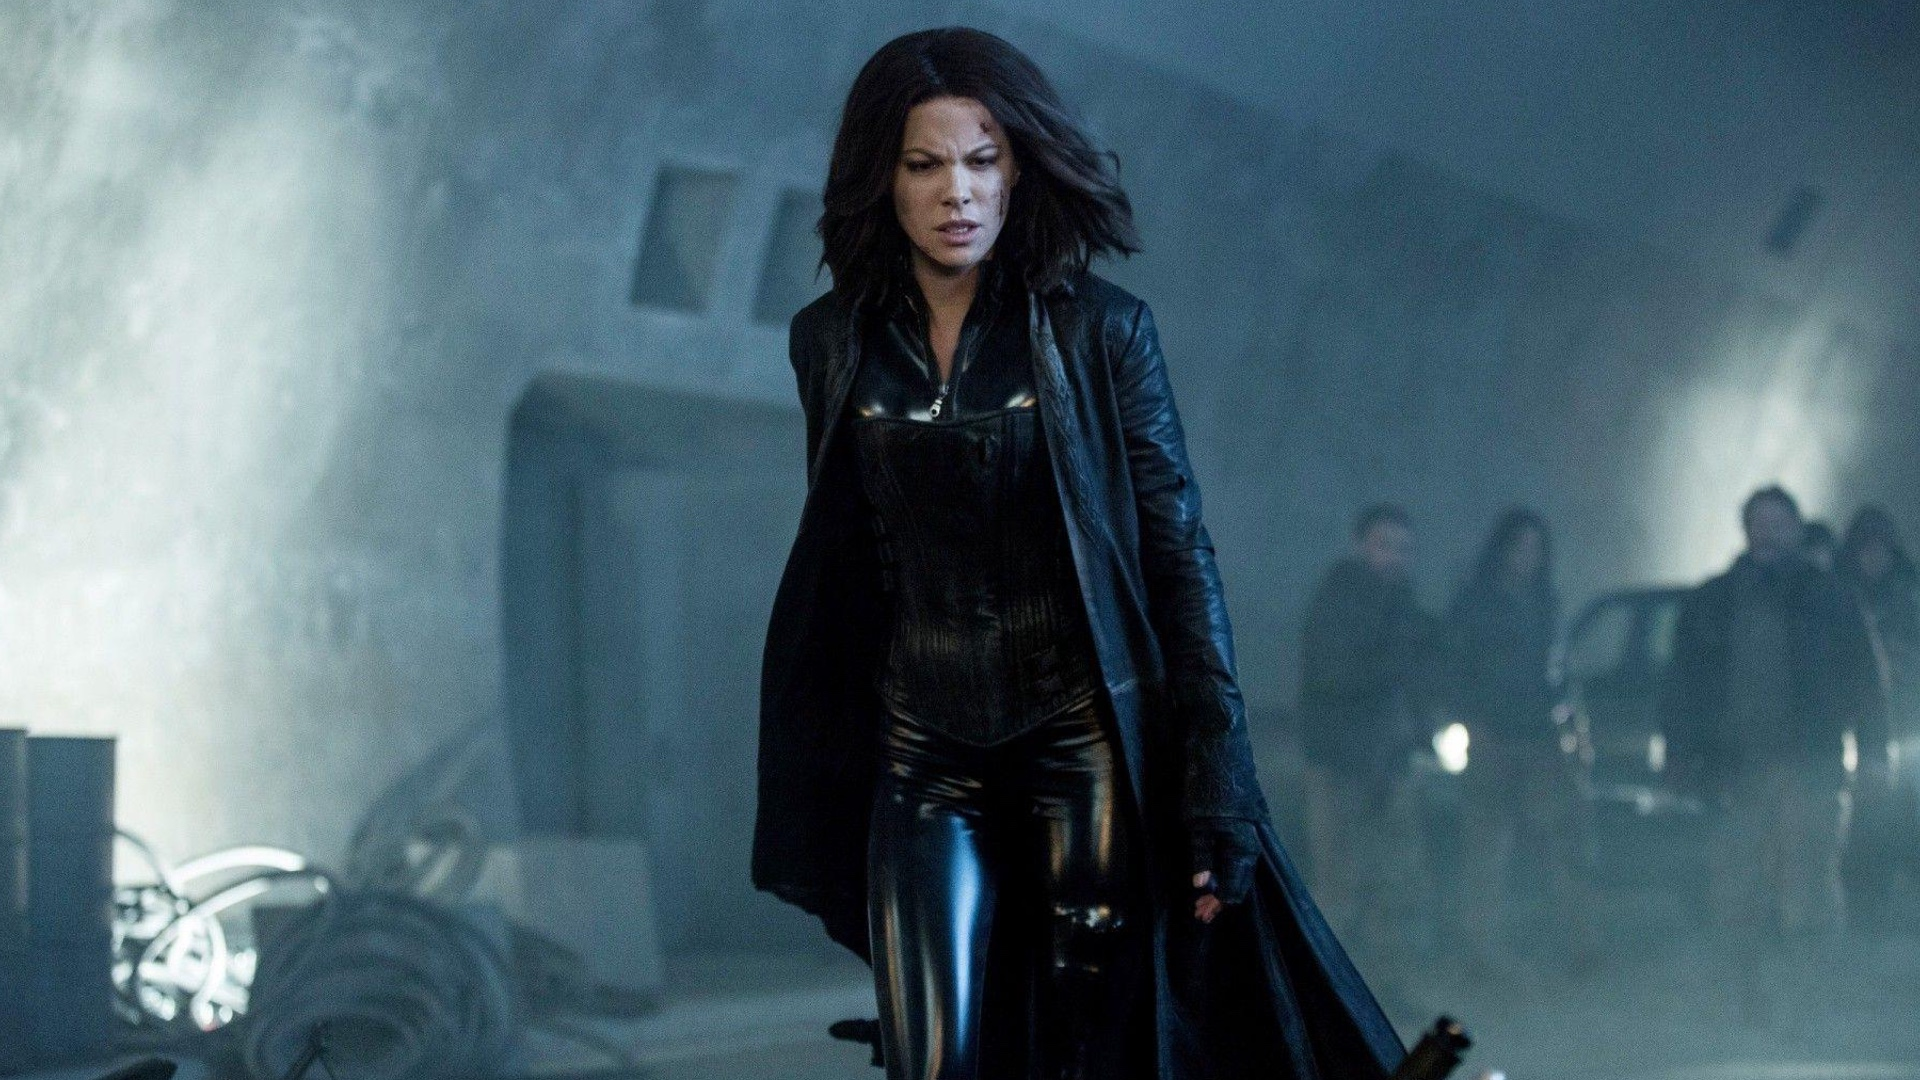What do you think is happening just beyond the frame? Beyond the frame, one might imagine the continuation of the industrial setting, with more machinery or deserted areas creating a labyrinthine environment. There could be other characters lurking in the shadows, unseen threats or allies connected to the narrative. The sense of motion and unresolved action implies that the scene is just a fragment of a larger, ongoing event. 